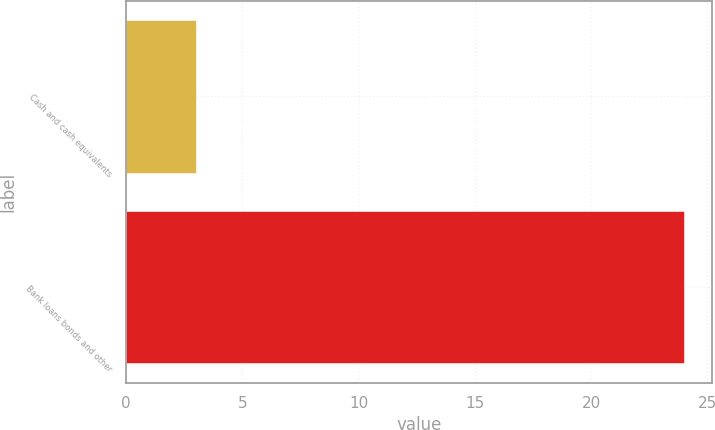<chart> <loc_0><loc_0><loc_500><loc_500><bar_chart><fcel>Cash and cash equivalents<fcel>Bank loans bonds and other<nl><fcel>3<fcel>24<nl></chart> 